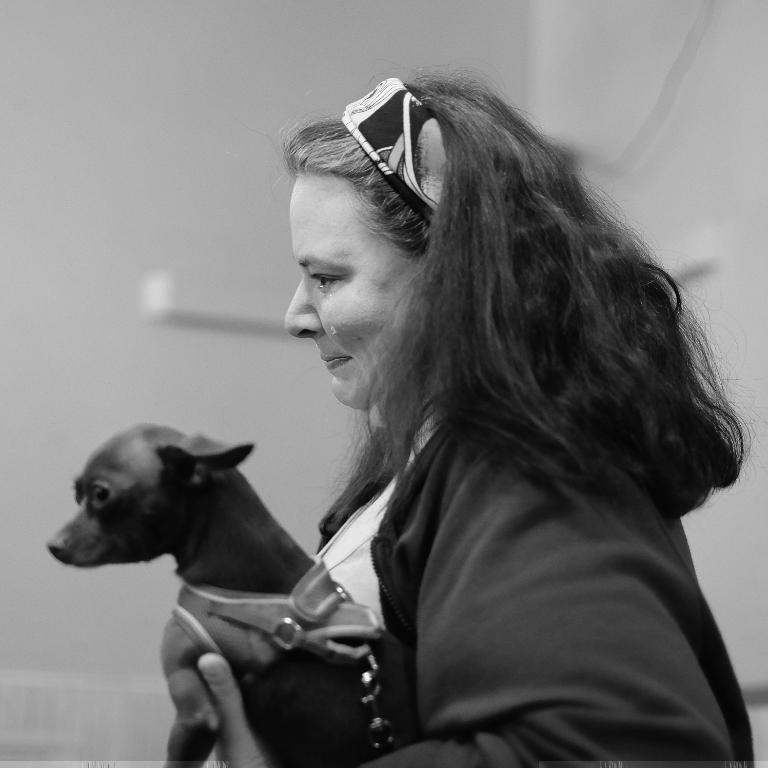What is the main subject of the image? There is a person in the center of the image. What is the person holding in the image? The person is holding a dog. How does the person appear to be feeling in the image? The person appears to be crying, as indicated by their facial expression. What type of sleet is falling on the person and the dog in the image? There is no mention of sleet or any weather condition in the image. The image only shows a person holding a dog and appearing to be crying. 